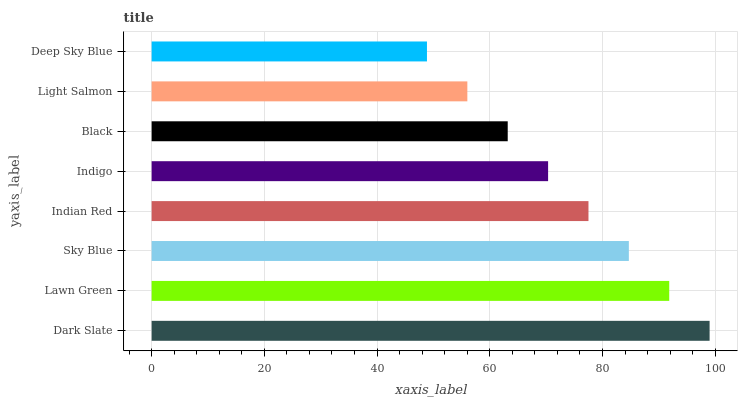Is Deep Sky Blue the minimum?
Answer yes or no. Yes. Is Dark Slate the maximum?
Answer yes or no. Yes. Is Lawn Green the minimum?
Answer yes or no. No. Is Lawn Green the maximum?
Answer yes or no. No. Is Dark Slate greater than Lawn Green?
Answer yes or no. Yes. Is Lawn Green less than Dark Slate?
Answer yes or no. Yes. Is Lawn Green greater than Dark Slate?
Answer yes or no. No. Is Dark Slate less than Lawn Green?
Answer yes or no. No. Is Indian Red the high median?
Answer yes or no. Yes. Is Indigo the low median?
Answer yes or no. Yes. Is Black the high median?
Answer yes or no. No. Is Sky Blue the low median?
Answer yes or no. No. 